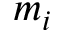<formula> <loc_0><loc_0><loc_500><loc_500>m _ { i }</formula> 